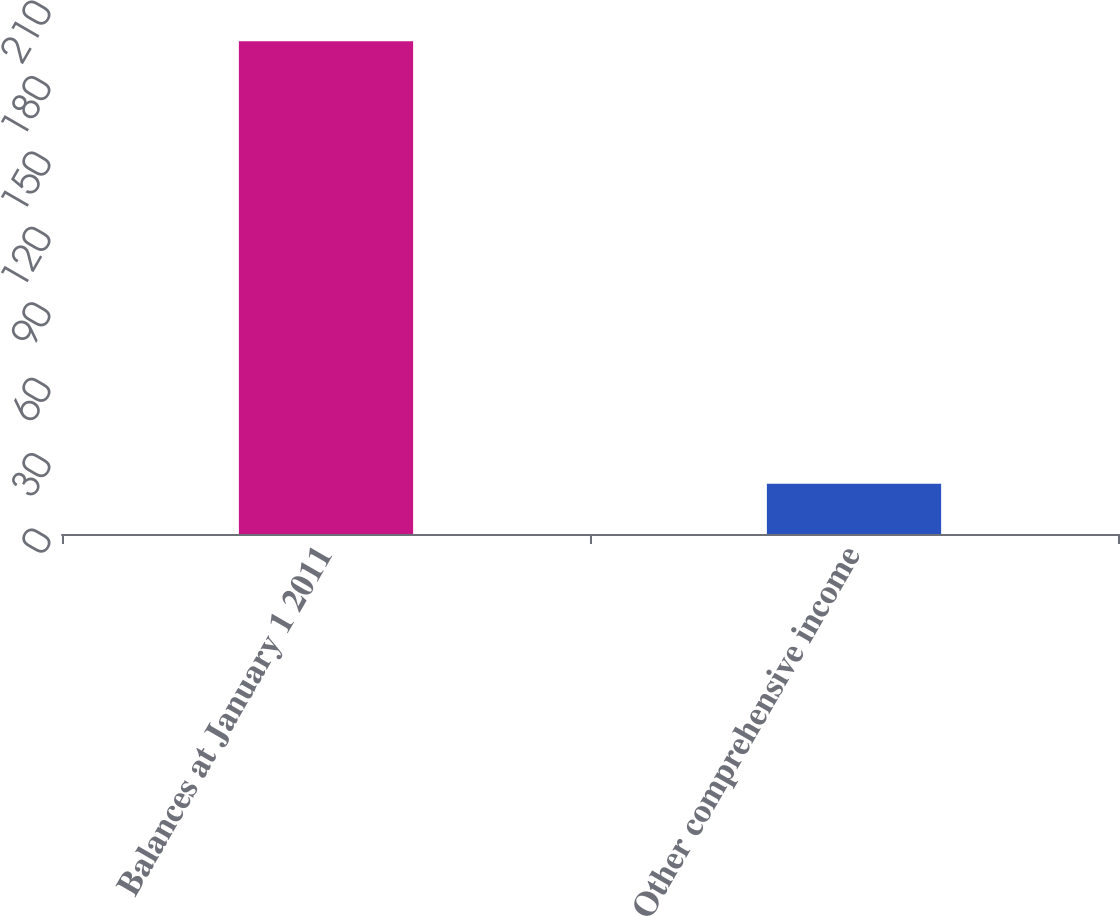Convert chart. <chart><loc_0><loc_0><loc_500><loc_500><bar_chart><fcel>Balances at January 1 2011<fcel>Other comprehensive income<nl><fcel>196<fcel>20<nl></chart> 